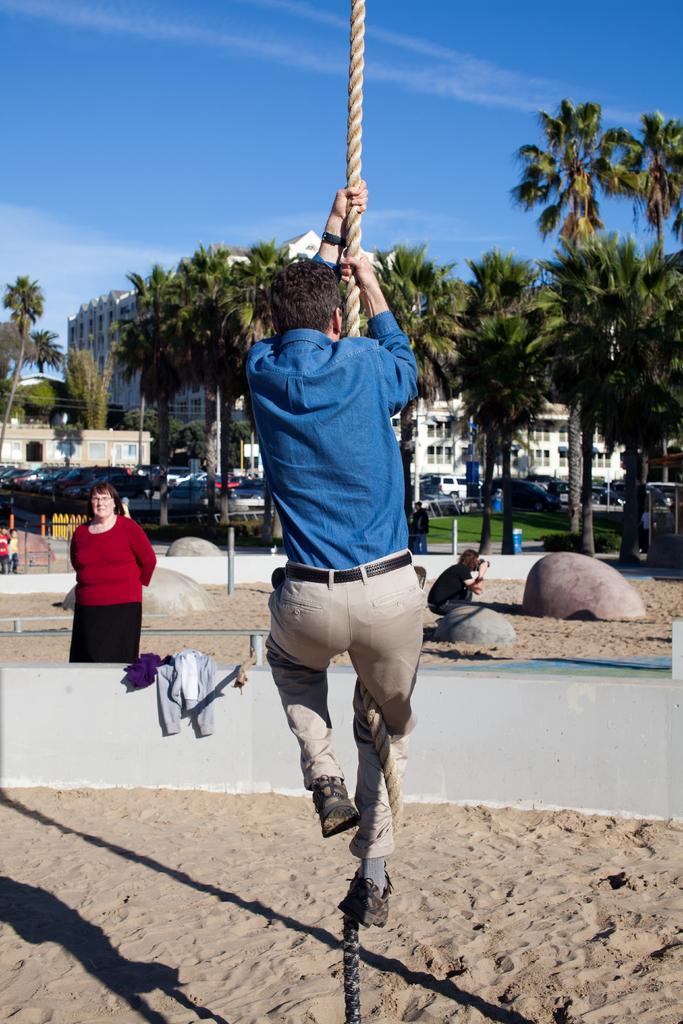Describe this image in one or two sentences. In the image I can see a person who is holding the rope and also I can see some other people, among them a person is holding the camera and some trees, buildings and some other things. 